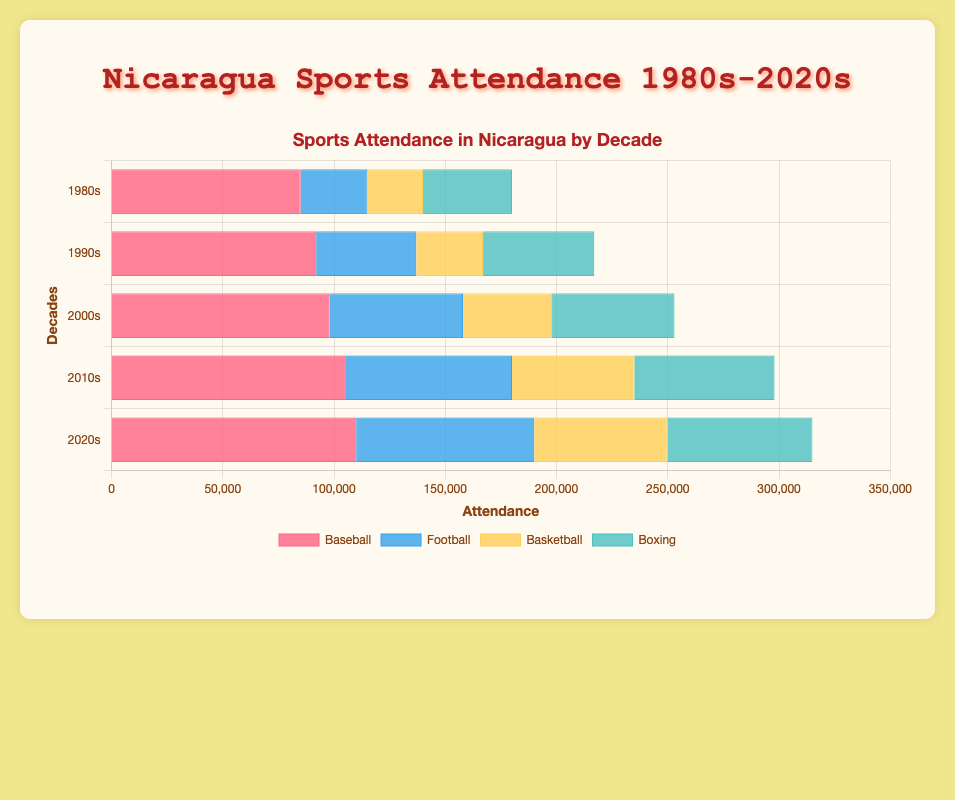How has the attendance of Baseball changed from the 1980s to the 2020s? In the 1980s, Baseball attendance was 85,000. By the 2020s, it increased to 110,000. The difference is 110,000 - 85,000 = 25,000.
Answer: Increased by 25,000 Which sport saw the highest increase in attendance from the 1980s to the 2020s? Calculate the increase for each sport: Baseball (110,000 - 85,000 = 25,000), Football (80,000 - 30,000 = 50,000), Basketball (60,000 - 25,000 = 35,000), Boxing (65,000 - 40,000 = 25,000). Football had the highest increase of 50,000.
Answer: Football In which decade was Football attendance higher than Basketball attendance by the greatest margin? Compare the difference in each decade: 1980s (30,000 - 25,000 = 5,000), 1990s (45,000 - 30,000 = 15,000), 2000s (60,000 - 40,000 = 20,000), 2010s (75,000 - 55,000 = 20,000), 2020s (80,000 - 60,000 = 20,000). The greatest margin is in the 2000s, 2010s, and 2020s with a difference of 20,000.
Answer: 2000s, 2010s, 2020s Which sport had the lowest attendance in the 1980s? In the 1980s, the attendance figures are: Baseball (85,000), Football (30,000), Basketball (25,000), Boxing (40,000). Basketball had the lowest figure at 25,000.
Answer: Basketball Which color represents Football in the chart and how can you tell? The color representing Football is the second one listed in the legend which is "blue". This can be verified by the bars in the chart corresponding to Football's attendance figures.
Answer: Blue In the 2010s, what is the total attendance for all sports combined? Sum up all the attendance figures for the 2010s: Baseball (105,000) + Football (75,000) + Basketball (55,000) + Boxing (63,000) = 298,000.
Answer: 298,000 How did the attendance for Boxing change from the 1990s to the 2000s? In the 1990s, Boxing attendance was 50,000. In the 2000s, it was 55,000. The difference is 55,000 - 50,000 = 5,000.
Answer: Increased by 5,000 